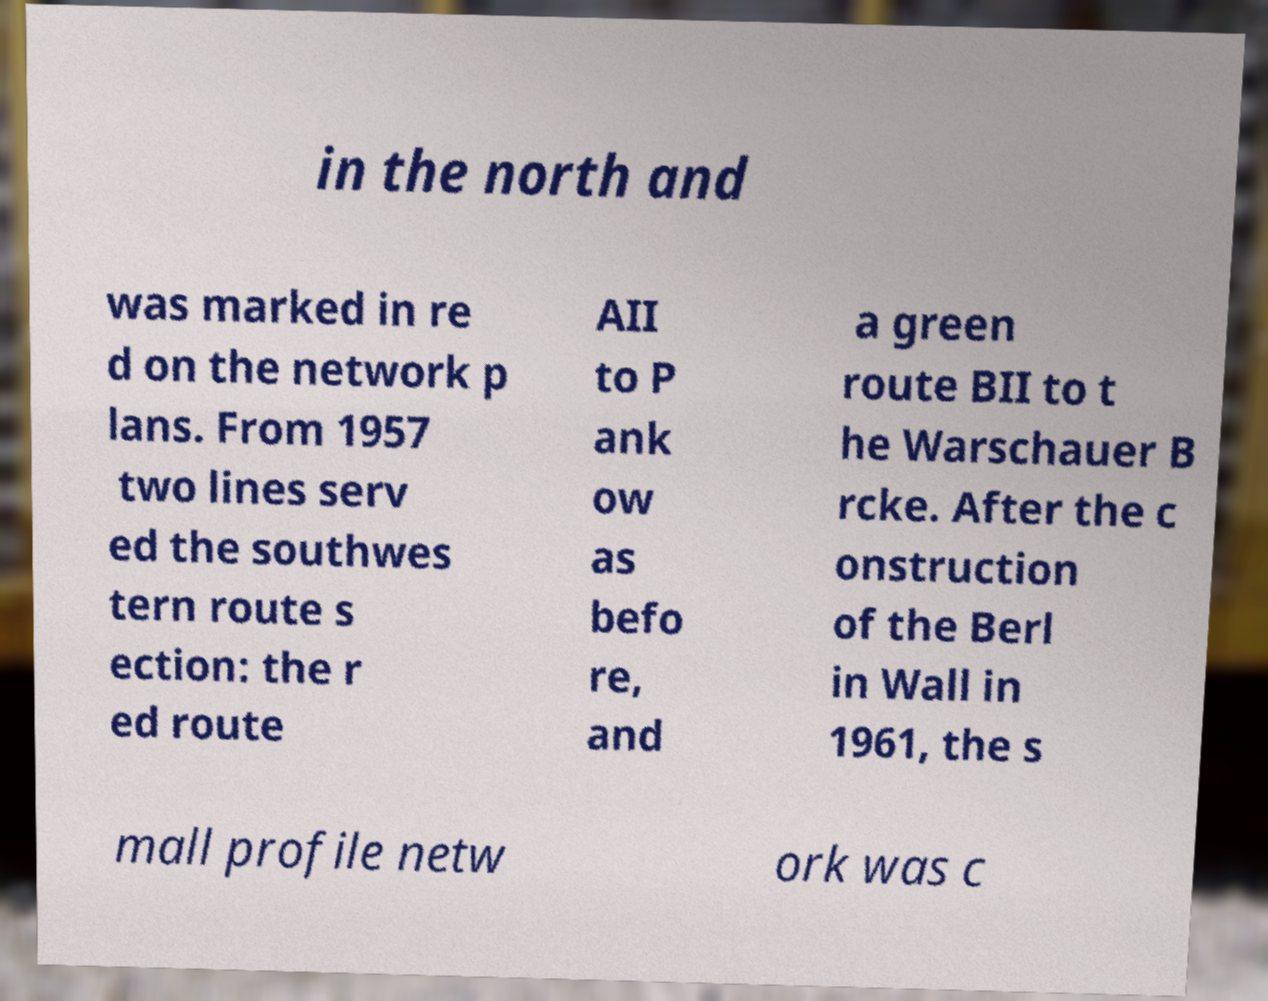I need the written content from this picture converted into text. Can you do that? in the north and was marked in re d on the network p lans. From 1957 two lines serv ed the southwes tern route s ection: the r ed route AII to P ank ow as befo re, and a green route BII to t he Warschauer B rcke. After the c onstruction of the Berl in Wall in 1961, the s mall profile netw ork was c 